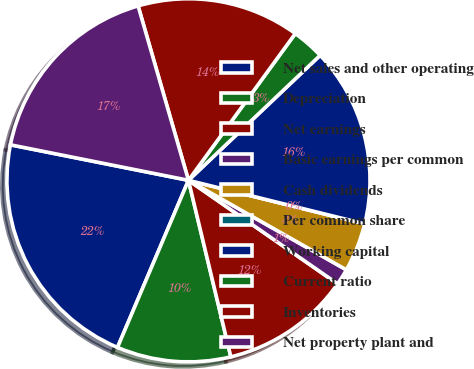Convert chart. <chart><loc_0><loc_0><loc_500><loc_500><pie_chart><fcel>Net sales and other operating<fcel>Depreciation<fcel>Net earnings<fcel>Basic earnings per common<fcel>Cash dividends<fcel>Per common share<fcel>Working capital<fcel>Current ratio<fcel>Inventories<fcel>Net property plant and<nl><fcel>21.74%<fcel>10.14%<fcel>11.59%<fcel>1.45%<fcel>4.35%<fcel>0.0%<fcel>15.94%<fcel>2.9%<fcel>14.49%<fcel>17.39%<nl></chart> 